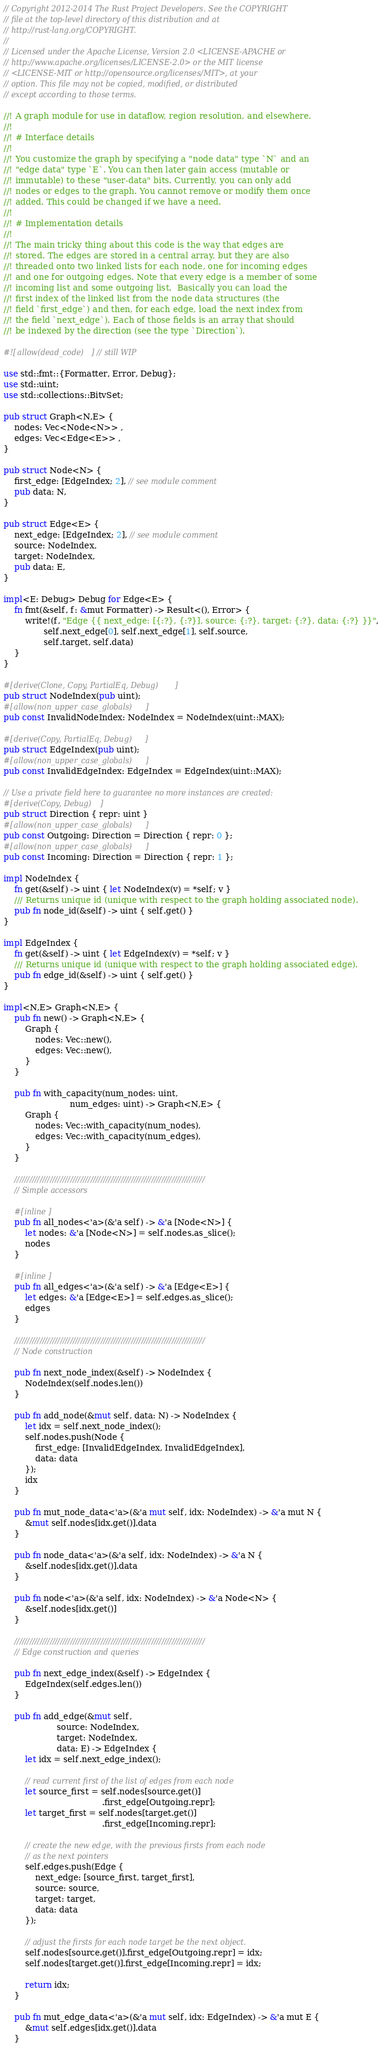Convert code to text. <code><loc_0><loc_0><loc_500><loc_500><_Rust_>// Copyright 2012-2014 The Rust Project Developers. See the COPYRIGHT
// file at the top-level directory of this distribution and at
// http://rust-lang.org/COPYRIGHT.
//
// Licensed under the Apache License, Version 2.0 <LICENSE-APACHE or
// http://www.apache.org/licenses/LICENSE-2.0> or the MIT license
// <LICENSE-MIT or http://opensource.org/licenses/MIT>, at your
// option. This file may not be copied, modified, or distributed
// except according to those terms.

//! A graph module for use in dataflow, region resolution, and elsewhere.
//!
//! # Interface details
//!
//! You customize the graph by specifying a "node data" type `N` and an
//! "edge data" type `E`. You can then later gain access (mutable or
//! immutable) to these "user-data" bits. Currently, you can only add
//! nodes or edges to the graph. You cannot remove or modify them once
//! added. This could be changed if we have a need.
//!
//! # Implementation details
//!
//! The main tricky thing about this code is the way that edges are
//! stored. The edges are stored in a central array, but they are also
//! threaded onto two linked lists for each node, one for incoming edges
//! and one for outgoing edges. Note that every edge is a member of some
//! incoming list and some outgoing list.  Basically you can load the
//! first index of the linked list from the node data structures (the
//! field `first_edge`) and then, for each edge, load the next index from
//! the field `next_edge`). Each of those fields is an array that should
//! be indexed by the direction (see the type `Direction`).

#![allow(dead_code)] // still WIP

use std::fmt::{Formatter, Error, Debug};
use std::uint;
use std::collections::BitvSet;

pub struct Graph<N,E> {
    nodes: Vec<Node<N>> ,
    edges: Vec<Edge<E>> ,
}

pub struct Node<N> {
    first_edge: [EdgeIndex; 2], // see module comment
    pub data: N,
}

pub struct Edge<E> {
    next_edge: [EdgeIndex; 2], // see module comment
    source: NodeIndex,
    target: NodeIndex,
    pub data: E,
}

impl<E: Debug> Debug for Edge<E> {
    fn fmt(&self, f: &mut Formatter) -> Result<(), Error> {
        write!(f, "Edge {{ next_edge: [{:?}, {:?}], source: {:?}, target: {:?}, data: {:?} }}",
               self.next_edge[0], self.next_edge[1], self.source,
               self.target, self.data)
    }
}

#[derive(Clone, Copy, PartialEq, Debug)]
pub struct NodeIndex(pub uint);
#[allow(non_upper_case_globals)]
pub const InvalidNodeIndex: NodeIndex = NodeIndex(uint::MAX);

#[derive(Copy, PartialEq, Debug)]
pub struct EdgeIndex(pub uint);
#[allow(non_upper_case_globals)]
pub const InvalidEdgeIndex: EdgeIndex = EdgeIndex(uint::MAX);

// Use a private field here to guarantee no more instances are created:
#[derive(Copy, Debug)]
pub struct Direction { repr: uint }
#[allow(non_upper_case_globals)]
pub const Outgoing: Direction = Direction { repr: 0 };
#[allow(non_upper_case_globals)]
pub const Incoming: Direction = Direction { repr: 1 };

impl NodeIndex {
    fn get(&self) -> uint { let NodeIndex(v) = *self; v }
    /// Returns unique id (unique with respect to the graph holding associated node).
    pub fn node_id(&self) -> uint { self.get() }
}

impl EdgeIndex {
    fn get(&self) -> uint { let EdgeIndex(v) = *self; v }
    /// Returns unique id (unique with respect to the graph holding associated edge).
    pub fn edge_id(&self) -> uint { self.get() }
}

impl<N,E> Graph<N,E> {
    pub fn new() -> Graph<N,E> {
        Graph {
            nodes: Vec::new(),
            edges: Vec::new(),
        }
    }

    pub fn with_capacity(num_nodes: uint,
                         num_edges: uint) -> Graph<N,E> {
        Graph {
            nodes: Vec::with_capacity(num_nodes),
            edges: Vec::with_capacity(num_edges),
        }
    }

    ///////////////////////////////////////////////////////////////////////////
    // Simple accessors

    #[inline]
    pub fn all_nodes<'a>(&'a self) -> &'a [Node<N>] {
        let nodes: &'a [Node<N>] = self.nodes.as_slice();
        nodes
    }

    #[inline]
    pub fn all_edges<'a>(&'a self) -> &'a [Edge<E>] {
        let edges: &'a [Edge<E>] = self.edges.as_slice();
        edges
    }

    ///////////////////////////////////////////////////////////////////////////
    // Node construction

    pub fn next_node_index(&self) -> NodeIndex {
        NodeIndex(self.nodes.len())
    }

    pub fn add_node(&mut self, data: N) -> NodeIndex {
        let idx = self.next_node_index();
        self.nodes.push(Node {
            first_edge: [InvalidEdgeIndex, InvalidEdgeIndex],
            data: data
        });
        idx
    }

    pub fn mut_node_data<'a>(&'a mut self, idx: NodeIndex) -> &'a mut N {
        &mut self.nodes[idx.get()].data
    }

    pub fn node_data<'a>(&'a self, idx: NodeIndex) -> &'a N {
        &self.nodes[idx.get()].data
    }

    pub fn node<'a>(&'a self, idx: NodeIndex) -> &'a Node<N> {
        &self.nodes[idx.get()]
    }

    ///////////////////////////////////////////////////////////////////////////
    // Edge construction and queries

    pub fn next_edge_index(&self) -> EdgeIndex {
        EdgeIndex(self.edges.len())
    }

    pub fn add_edge(&mut self,
                    source: NodeIndex,
                    target: NodeIndex,
                    data: E) -> EdgeIndex {
        let idx = self.next_edge_index();

        // read current first of the list of edges from each node
        let source_first = self.nodes[source.get()]
                                     .first_edge[Outgoing.repr];
        let target_first = self.nodes[target.get()]
                                     .first_edge[Incoming.repr];

        // create the new edge, with the previous firsts from each node
        // as the next pointers
        self.edges.push(Edge {
            next_edge: [source_first, target_first],
            source: source,
            target: target,
            data: data
        });

        // adjust the firsts for each node target be the next object.
        self.nodes[source.get()].first_edge[Outgoing.repr] = idx;
        self.nodes[target.get()].first_edge[Incoming.repr] = idx;

        return idx;
    }

    pub fn mut_edge_data<'a>(&'a mut self, idx: EdgeIndex) -> &'a mut E {
        &mut self.edges[idx.get()].data
    }
</code> 